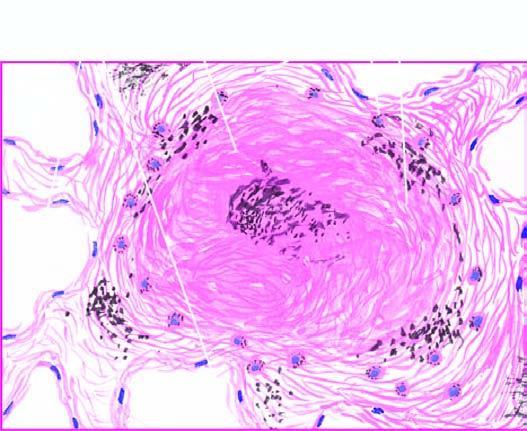what does the silicotic nodule consist of?
Answer the question using a single word or phrase. Hyaline centre surrounded by concentric layers of collagen 